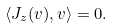<formula> <loc_0><loc_0><loc_500><loc_500>\left \langle J _ { z } ( v ) , v \right \rangle = 0 .</formula> 